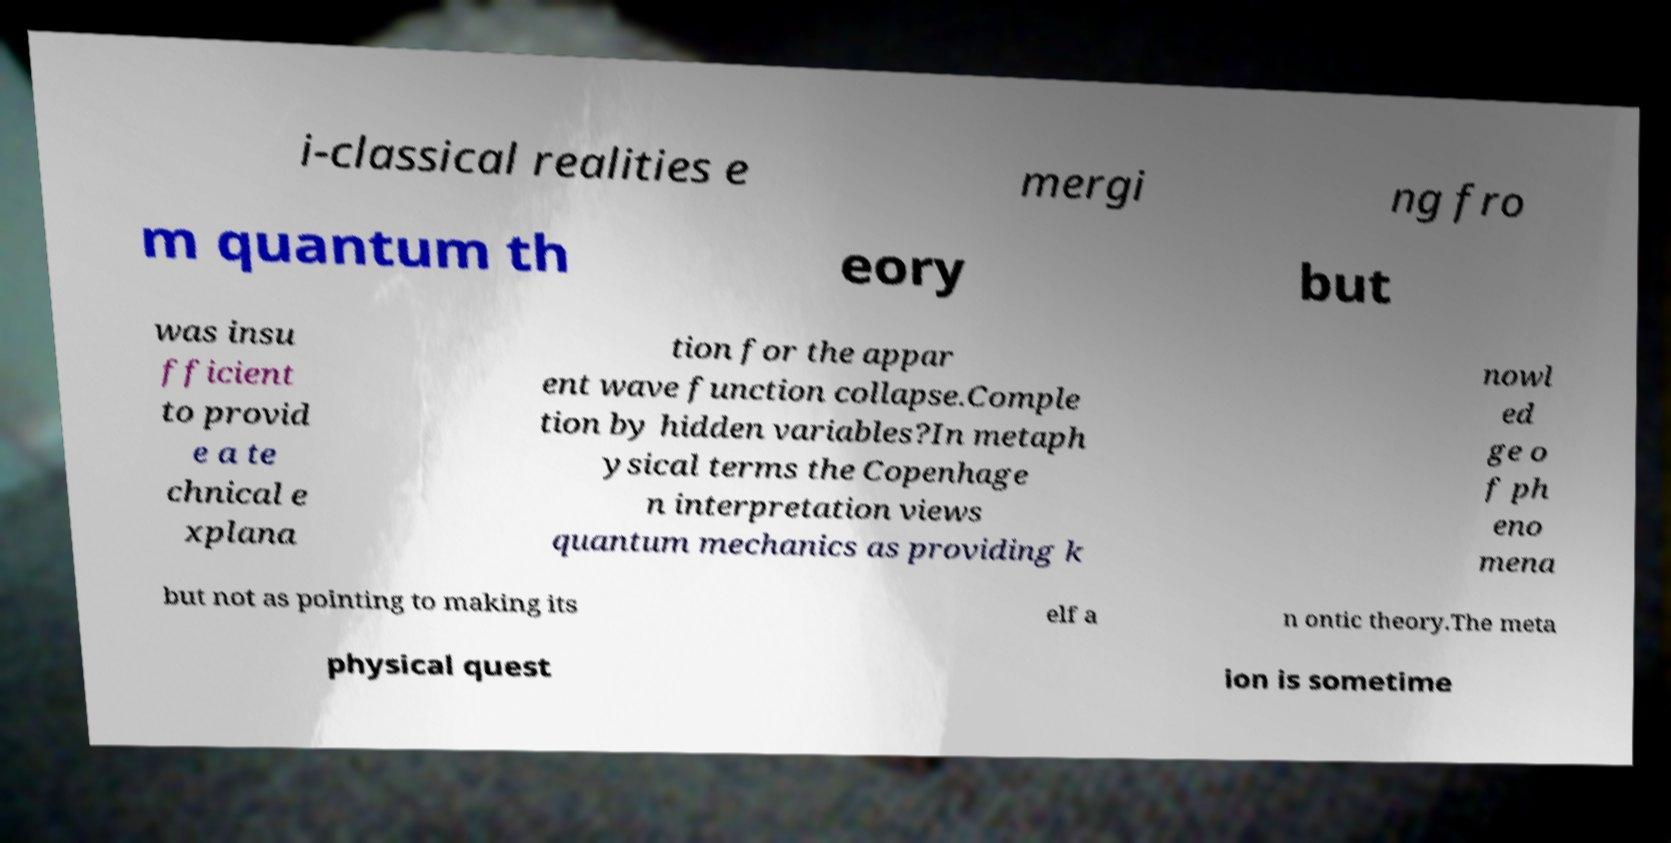Can you accurately transcribe the text from the provided image for me? i-classical realities e mergi ng fro m quantum th eory but was insu fficient to provid e a te chnical e xplana tion for the appar ent wave function collapse.Comple tion by hidden variables?In metaph ysical terms the Copenhage n interpretation views quantum mechanics as providing k nowl ed ge o f ph eno mena but not as pointing to making its elf a n ontic theory.The meta physical quest ion is sometime 